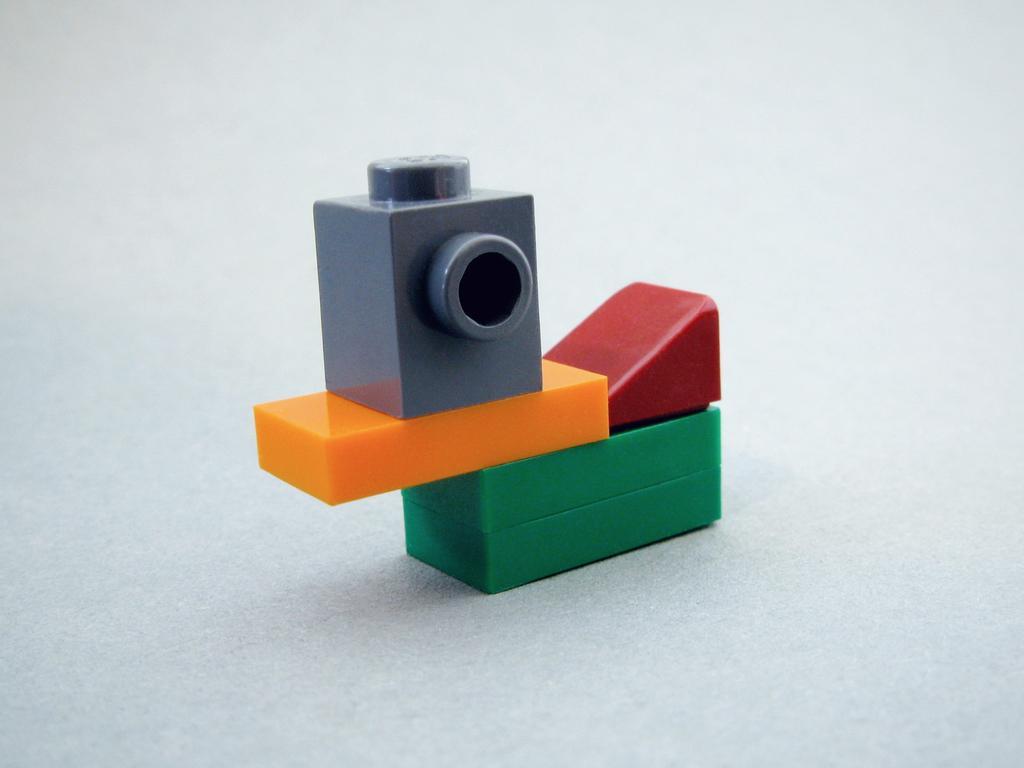How would you summarize this image in a sentence or two? In this image I can see few blocks in multi color and I can see the white color background. 